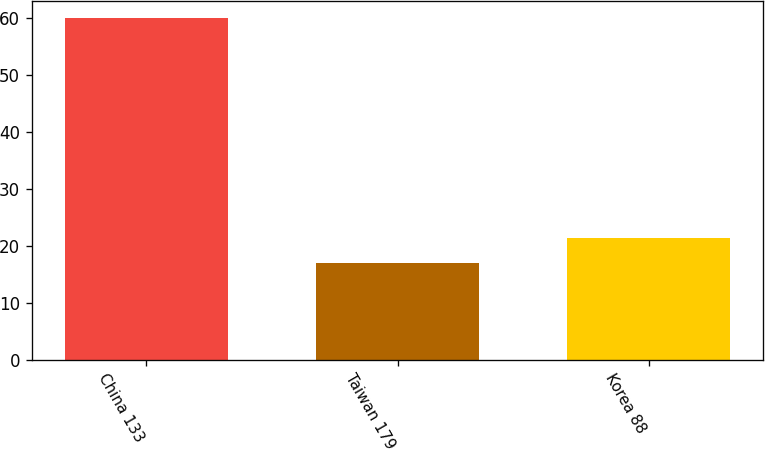<chart> <loc_0><loc_0><loc_500><loc_500><bar_chart><fcel>China 133<fcel>Taiwan 179<fcel>Korea 88<nl><fcel>60<fcel>17<fcel>21.3<nl></chart> 